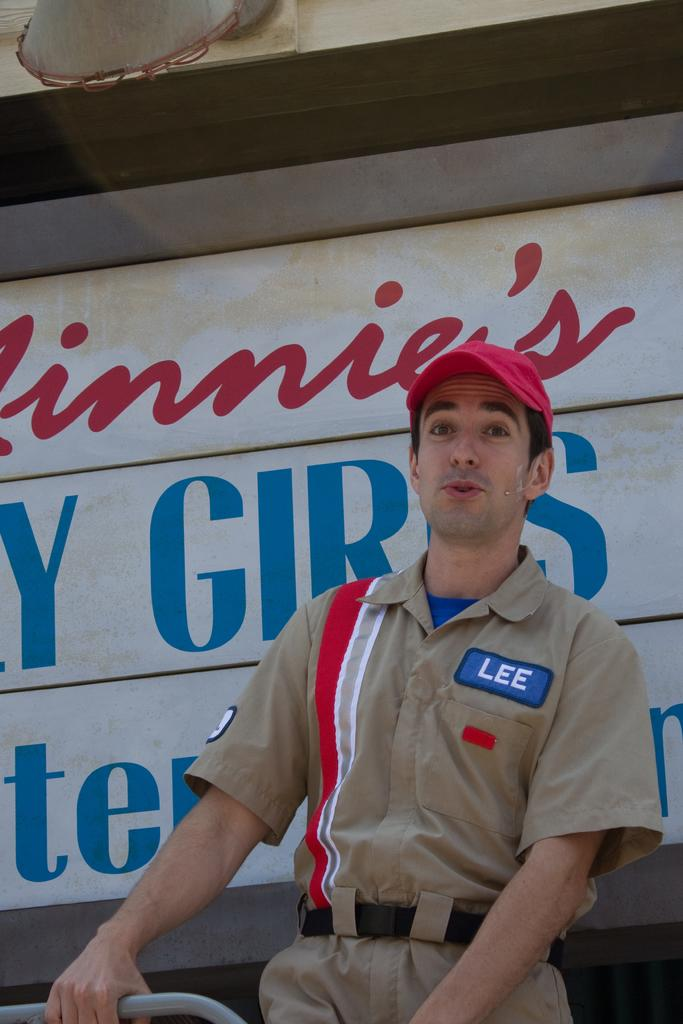What is the main subject of the image? There is a man in the image. What is the man doing in the image? The man is standing in the image. What is the man holding in the image? The man is holding an iron rod in the image. What can be seen in the background of the image? There is a board and an object in the background of the image. Can you see any ghosts interacting with the man in the image? There are no ghosts present in the image. What type of shelf can be seen behind the man in the image? There is no shelf visible in the image; only a board and an object are present in the background. 